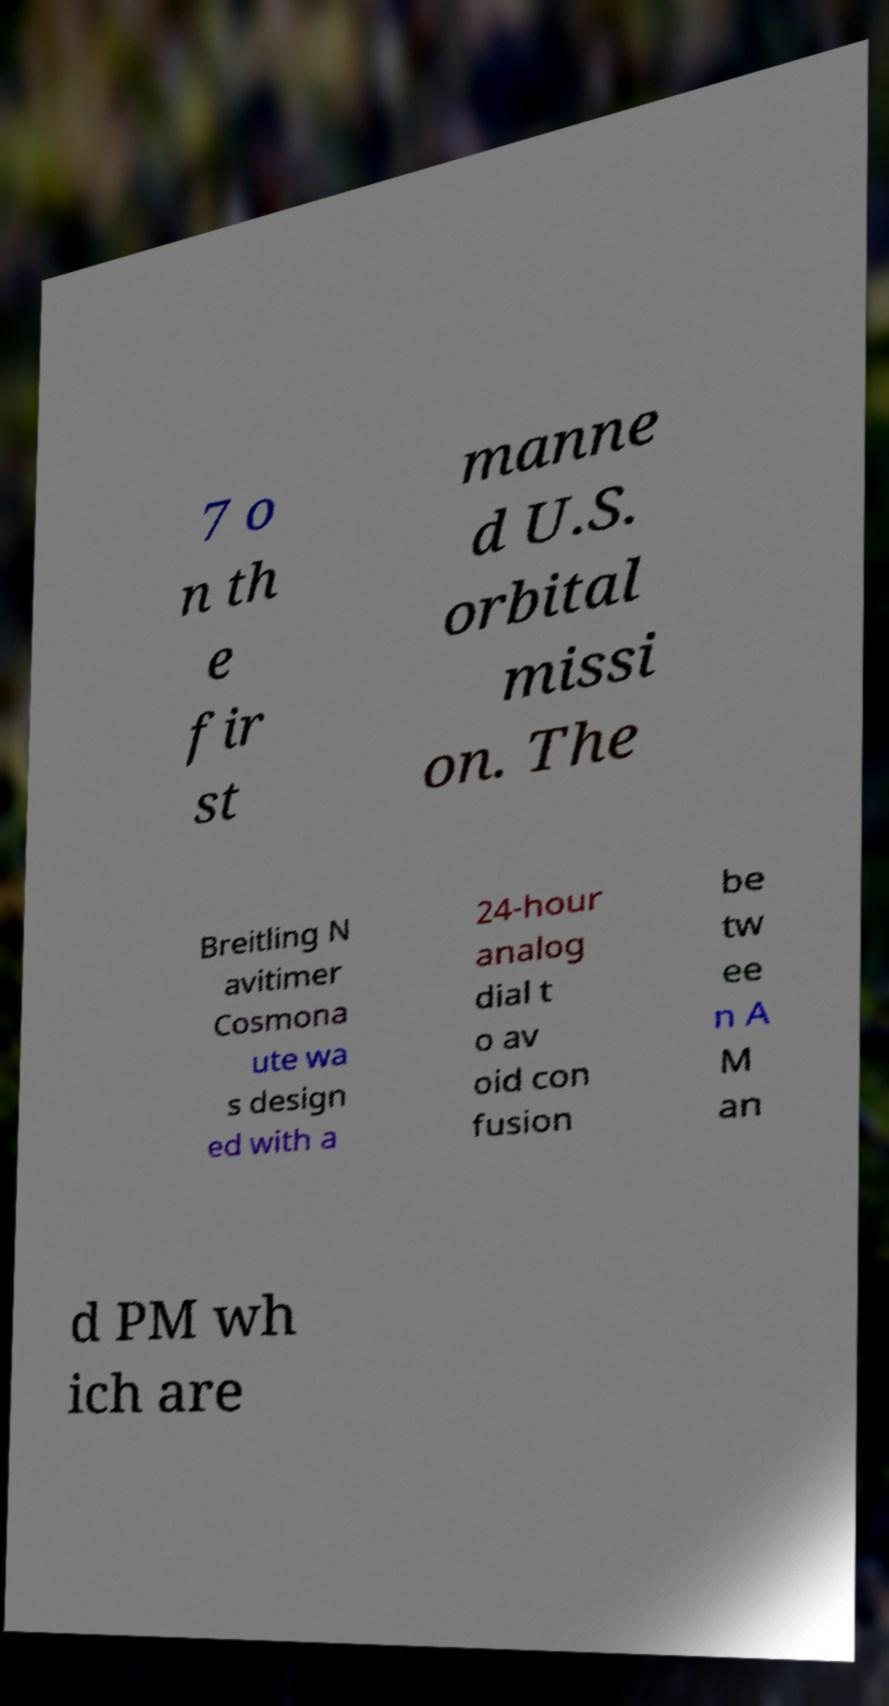I need the written content from this picture converted into text. Can you do that? 7 o n th e fir st manne d U.S. orbital missi on. The Breitling N avitimer Cosmona ute wa s design ed with a 24-hour analog dial t o av oid con fusion be tw ee n A M an d PM wh ich are 